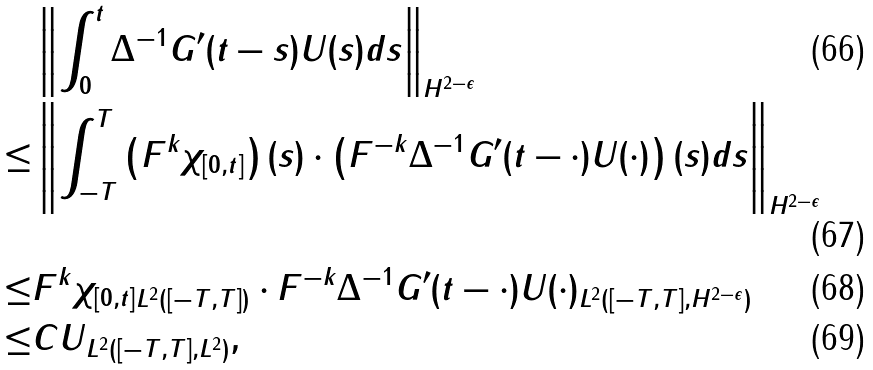<formula> <loc_0><loc_0><loc_500><loc_500>& \left \| \int _ { 0 } ^ { t } \Delta ^ { - 1 } G ^ { \prime } ( t - s ) U ( s ) d s \right \| _ { H ^ { 2 - \epsilon } } \\ \leq & \left \| \int _ { - T } ^ { T } \left ( F ^ { k } \chi _ { [ 0 , t ] } \right ) ( s ) \cdot \left ( F ^ { - k } \Delta ^ { - 1 } G ^ { \prime } ( t - \cdot ) U ( \cdot ) \right ) ( s ) d s \right \| _ { H ^ { 2 - \epsilon } } \\ \leq & \| F ^ { k } \chi _ { [ 0 , t ] } \| _ { L ^ { 2 } ( [ - T , T ] ) } \cdot \| F ^ { - k } \Delta ^ { - 1 } G ^ { \prime } ( t - \cdot ) U ( \cdot ) \| _ { L ^ { 2 } ( [ - T , T ] , H ^ { 2 - \epsilon } ) } \\ \leq & C \| U \| _ { L ^ { 2 } ( [ - T , T ] , L ^ { 2 } ) } ,</formula> 